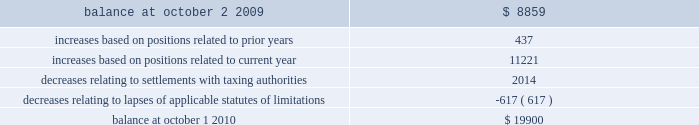31mar201122064257 notes to consolidated financial statements ( continued ) 10 .
Income taxes ( continued ) a reconciliation of the beginning and ending amount of gross unrecognized tax benefits is as follows ( in thousands ) : .
The company 2019s major tax jurisdictions as of october 1 , 2010 are the united states , california , and iowa .
For the united states , the company has open tax years dating back to fiscal year 1998 due to the carry forward of tax attributes .
For california and iowa , the company has open tax years dating back to fiscal year 2002 due to the carry forward of tax attributes .
During the year ended october 1 , 2010 , $ 0.6 million of previously unrecognized tax benefits related to the expiration of the statute of limitations period were recognized .
The company 2019s policy is to recognize accrued interest and penalties , if incurred , on any unrecognized tax benefits as a component of income tax expense .
The company did not incur any significant accrued interest or penalties related to unrecognized tax benefits during fiscal year 2010 .
11 .
Stockholders 2019 equity common stock the company is authorized to issue ( 1 ) 525000000 shares of common stock , par value $ 0.25 per share , and ( 2 ) 25000000 shares of preferred stock , without par value .
Holders of the company 2019s common stock are entitled to such dividends as may be declared by the company 2019s board of directors out of funds legally available for such purpose .
Dividends may not be paid on common stock unless all accrued dividends on preferred stock , if any , have been paid or declared and set aside .
In the event of the company 2019s liquidation , dissolution or winding up , the holders of common stock will be entitled to share pro rata in the assets remaining after payment to creditors and after payment of the liquidation preference plus any unpaid dividends to holders of any outstanding preferred stock .
Each holder of the company 2019s common stock is entitled to one vote for each such share outstanding in the holder 2019s name .
No holder of common stock is entitled to cumulate votes in voting for directors .
The company 2019s second amended and restated certificate of incorporation provides that , unless otherwise determined by the company 2019s board of directors , no holder of common stock has any preemptive right to purchase or subscribe for any stock of any class which the company may issue or on august 3 , 2010 , the company 2019s board of directors approved a stock repurchase program , pursuant to which the company is authorized to repurchase up to $ 200 million of the company 2019s common stock from time to time on the open market or in privately negotiated transactions as permitted by securities laws and other legal requirements .
The company had not repurchased any shares under the program for the fiscal year ended october 1 , 2010 .
As of november 29 , 2010 , the skyworks / 2010 annual report 137 .
What was the percentage change in the gross unrecognized tax benefits in 2010? 
Computations: ((19900 - 8859) / 8859)
Answer: 1.2463. 